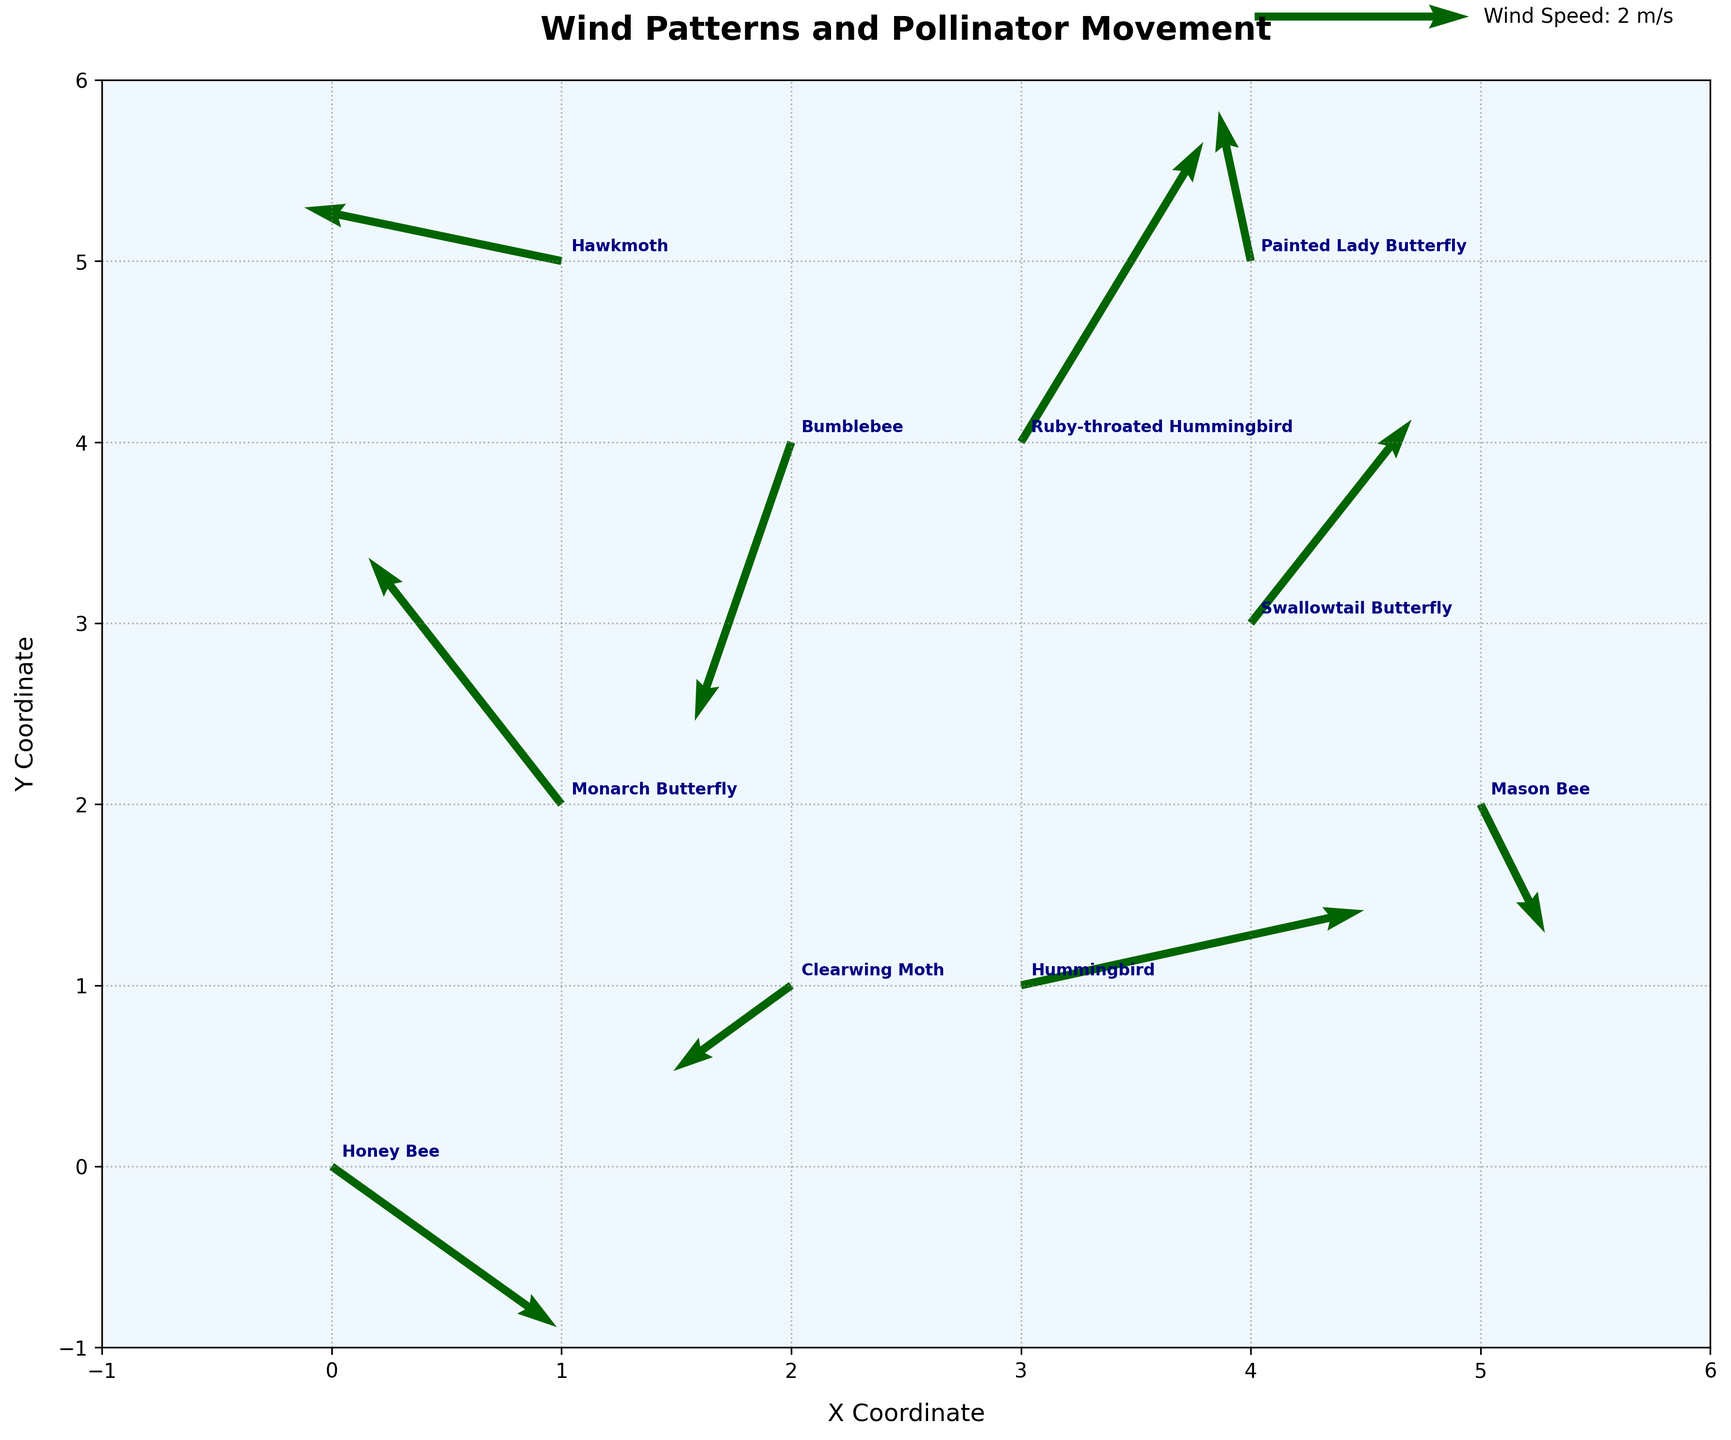What's the title of the plot? The title is located at the top center of the plot. It is formatted in a larger, bold font to emphasize the main topic of the visualization.
Answer: Wind Patterns and Pollinator Movement What are the X and Y coordinates of the Monarch Butterfly? The X and Y coordinates of the Monarch Butterfly can be found by locating its label in the plot. The label is placed next to the corresponding vector.
Answer: (1, 2) Which species is moving with the largest vertical component, and what is its value? To determine this, we need to examine the V values and identify the vector with the largest magnitude (ignoring sign). The largest vertical component is 2.8, associated with Ruby-throated Hummingbird.
Answer: Ruby-throated Hummingbird, 2.8 What is the average horizontal (X) coordinate of all the species? Sum the X coordinates of all species and divide by the number of species. Coordinates: 0, 1, 3, 2, 4, 1, 5, 3, 2, 4. Sum: 0 + 1 + 3 + 2 + 4 + 1 + 5 + 3 + 2 + 4 = 25, Number of species: 10. Average: 25/10 = 2.5
Answer: 2.5 What is the total distance traveled by Honey Bee in the plot? The distance is calculated using the equation sqrt(u^2 + v^2), where u and v are the horizontal and vertical components. Honey Bee’s values: u=2.1, v=-1.5. Distance = sqrt(2.1^2 + (-1.5)^2) ≈ sqrt(4.41 + 2.25) ≈ sqrt(6.66) ≈ 2.58
Answer: ≈ 2.58 Which species travels in a mostly downward direction? A downward direction means the V component is significantly negative. Among the V values, Hawkmoth has a relatively small V component of 0.5.
Answer: Bumblebee with V component -2.6 Which species has the smallest horizontal movement? We look for the species with the horizontal component (U value) closest to zero. Painted Lady Butterfly has the smallest horizontal movement with a U value of -0.3.
Answer: Painted Lady Butterfly Compare the movement direction of the Hawkmoth and Swallowtail Butterfly. Who moves more horizontally? To compare horizontal movements, check the U values of both species: Hawkmoth U=-2.4, Swallowtail Butterfly U=1.5. The absolute value shows Hawkmoth has a larger horizontal movement distance.
Answer: Hawkmoth How do the bees (Honey Bee, Bumblebee, Mason Bee) differ in their movement vectors? Examine the U and V components for each bee: Honey Bee (u=2.1, v=-1.5), Bumblebee (u=-0.9, v=-2.6), Mason Bee (u=0.6, v=-1.2). Honey Bee moves right-down, Bumblebee moves left-down, and Mason Bee moves slightly right-down.
Answer: Honey Bee right-down, Bumblebee left-down, Mason Bee slightly right-down What is the main color used in the quiver plot to represent the vectors? The main color used for the vectors is darkgreen, which indicates the movement and wind patterns.
Answer: darkgreen 